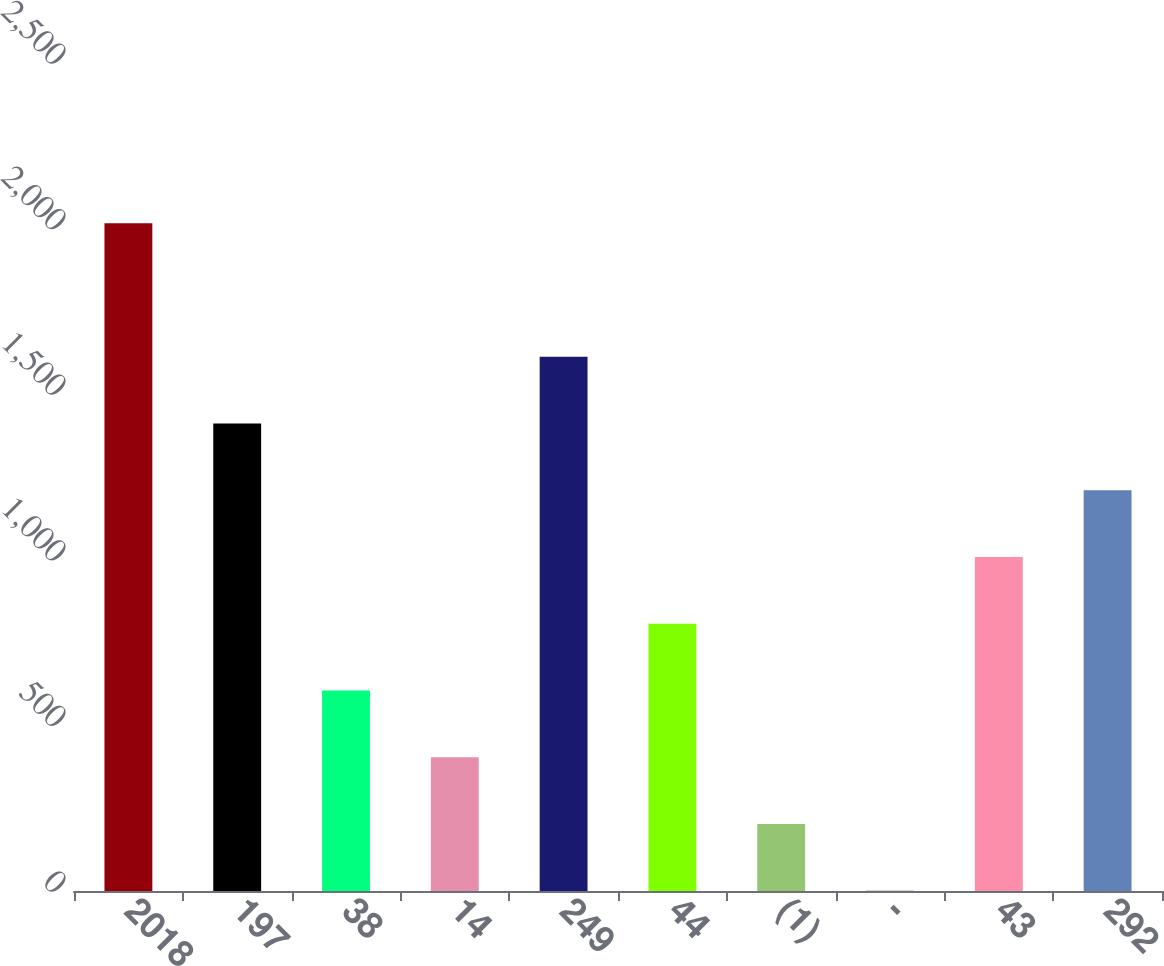<chart> <loc_0><loc_0><loc_500><loc_500><bar_chart><fcel>2018<fcel>197<fcel>38<fcel>14<fcel>249<fcel>44<fcel>(1)<fcel>-<fcel>43<fcel>292<nl><fcel>2016<fcel>1411.5<fcel>605.5<fcel>404<fcel>1613<fcel>807<fcel>202.5<fcel>1<fcel>1008.5<fcel>1210<nl></chart> 